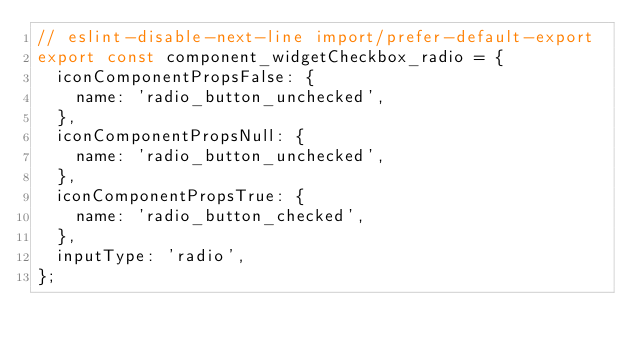<code> <loc_0><loc_0><loc_500><loc_500><_JavaScript_>// eslint-disable-next-line import/prefer-default-export
export const component_widgetCheckbox_radio = {
  iconComponentPropsFalse: {
    name: 'radio_button_unchecked',
  },
  iconComponentPropsNull: {
    name: 'radio_button_unchecked',
  },
  iconComponentPropsTrue: {
    name: 'radio_button_checked',
  },
  inputType: 'radio',
};
</code> 